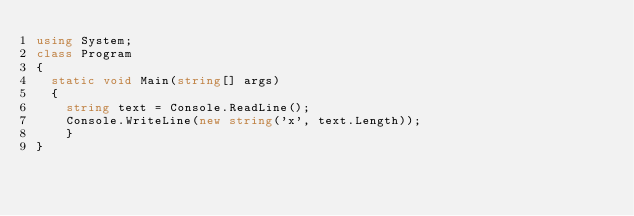<code> <loc_0><loc_0><loc_500><loc_500><_C#_>using System;
class Program
{
	static void Main(string[] args)
	{
		string text = Console.ReadLine();
		Console.WriteLine(new string('x', text.Length));
    }
}</code> 